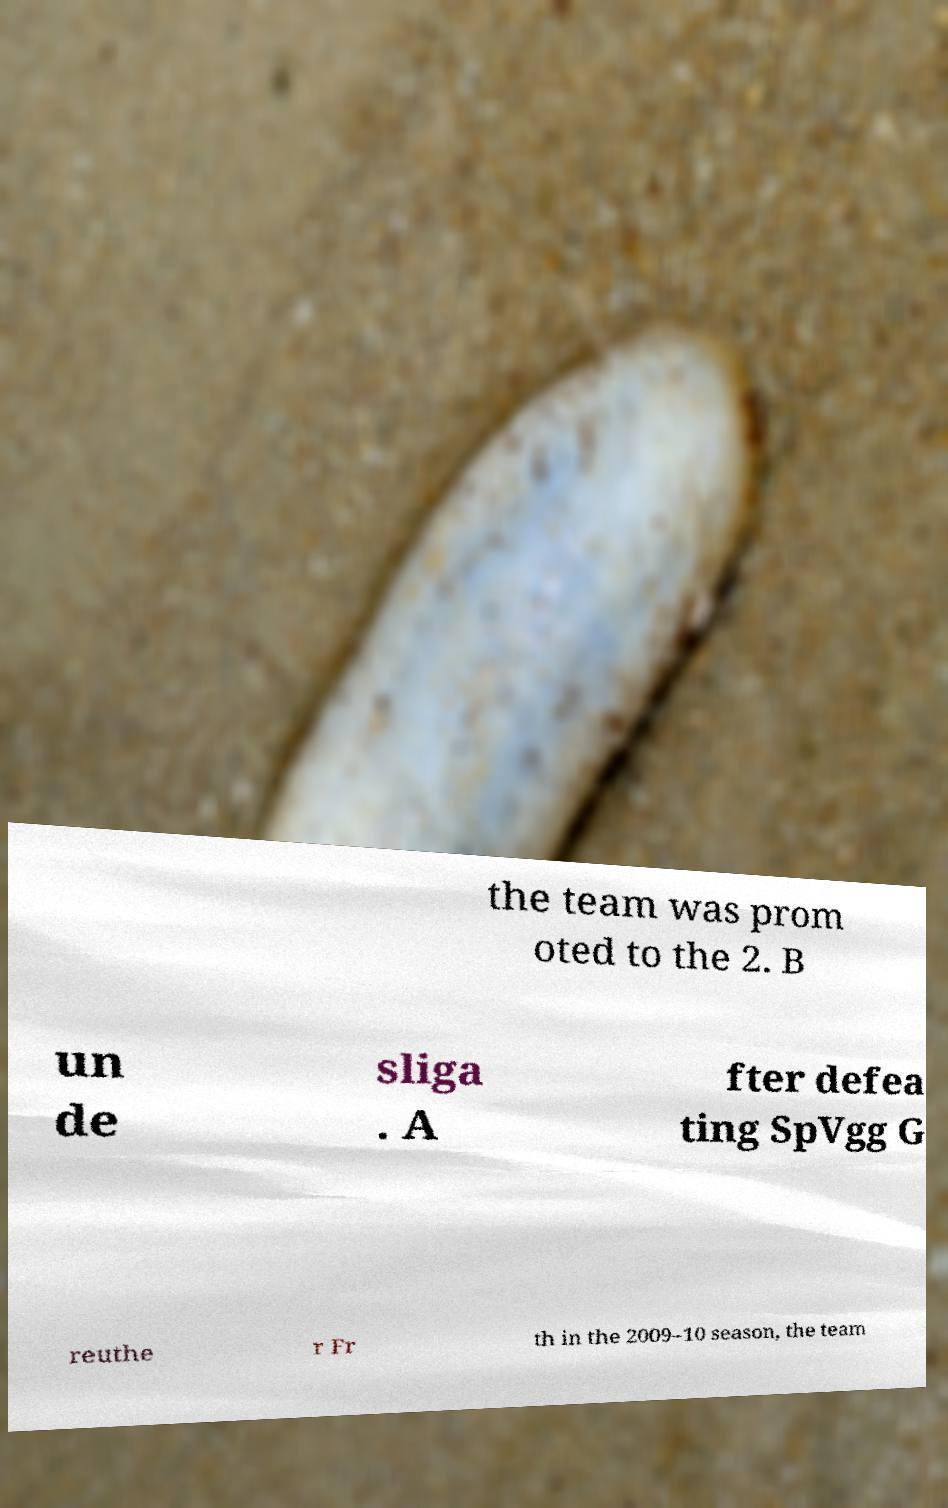I need the written content from this picture converted into text. Can you do that? the team was prom oted to the 2. B un de sliga . A fter defea ting SpVgg G reuthe r Fr th in the 2009–10 season, the team 